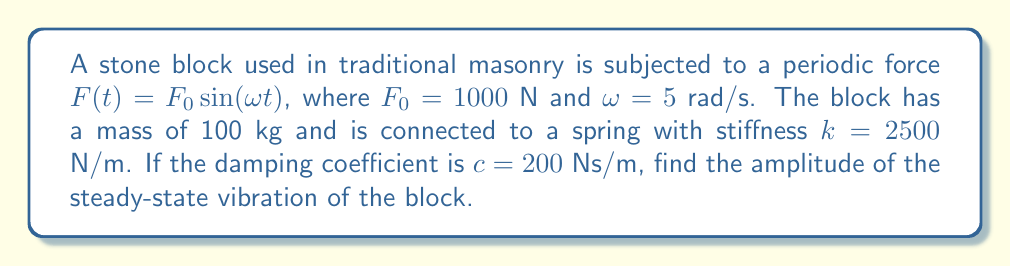Can you solve this math problem? To solve this problem, we'll follow these steps:

1) The equation of motion for a forced vibration system is:

   $$m\ddot{x} + c\dot{x} + kx = F_0 \sin(\omega t)$$

2) For steady-state vibration, the amplitude of the response is given by:

   $$X = \frac{F_0}{\sqrt{(k-m\omega^2)^2 + (c\omega)^2}}$$

3) Let's substitute the given values:
   $m = 100$ kg
   $c = 200$ Ns/m
   $k = 2500$ N/m
   $F_0 = 1000$ N
   $\omega = 5$ rad/s

4) First, calculate $k-m\omega^2$:
   $$k-m\omega^2 = 2500 - 100(5^2) = 2500 - 2500 = 0$$

5) Now, calculate $c\omega$:
   $$c\omega = 200 * 5 = 1000$$

6) Substitute these into the amplitude equation:

   $$X = \frac{1000}{\sqrt{0^2 + 1000^2}} = \frac{1000}{1000} = 1$$

Therefore, the amplitude of the steady-state vibration is 1 meter.
Answer: 1 m 